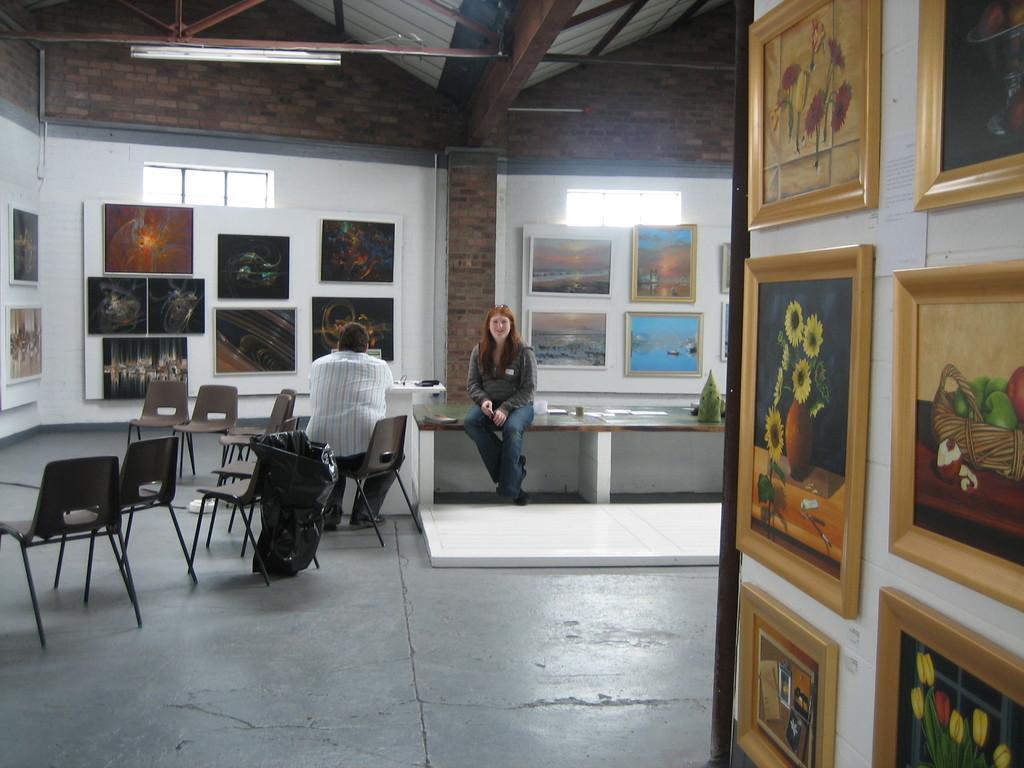Please provide a concise description of this image. in the picture there are many frames in the room many chairs and a person and a woman are sitting side by side. 